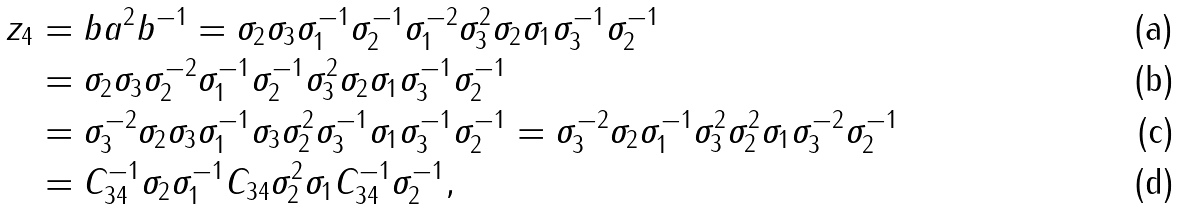Convert formula to latex. <formula><loc_0><loc_0><loc_500><loc_500>z _ { 4 } & = b a ^ { 2 } b ^ { - 1 } = \sigma _ { 2 } \sigma _ { 3 } \sigma _ { 1 } ^ { - 1 } \sigma _ { 2 } ^ { - 1 } \sigma _ { 1 } ^ { - 2 } \sigma _ { 3 } ^ { 2 } \sigma _ { 2 } \sigma _ { 1 } \sigma _ { 3 } ^ { - 1 } \sigma _ { 2 } ^ { - 1 } \\ & = \sigma _ { 2 } \sigma _ { 3 } \sigma _ { 2 } ^ { - 2 } \sigma _ { 1 } ^ { - 1 } \sigma _ { 2 } ^ { - 1 } \sigma _ { 3 } ^ { 2 } \sigma _ { 2 } \sigma _ { 1 } \sigma _ { 3 } ^ { - 1 } \sigma _ { 2 } ^ { - 1 } \\ & = \sigma _ { 3 } ^ { - 2 } \sigma _ { 2 } \sigma _ { 3 } \sigma _ { 1 } ^ { - 1 } \sigma _ { 3 } \sigma _ { 2 } ^ { 2 } \sigma _ { 3 } ^ { - 1 } \sigma _ { 1 } \sigma _ { 3 } ^ { - 1 } \sigma _ { 2 } ^ { - 1 } = \sigma _ { 3 } ^ { - 2 } \sigma _ { 2 } \sigma _ { 1 } ^ { - 1 } \sigma _ { 3 } ^ { 2 } \sigma _ { 2 } ^ { 2 } \sigma _ { 1 } \sigma _ { 3 } ^ { - 2 } \sigma _ { 2 } ^ { - 1 } \\ & = C _ { 3 4 } ^ { - 1 } \sigma _ { 2 } \sigma _ { 1 } ^ { - 1 } C _ { 3 4 } \sigma _ { 2 } ^ { 2 } \sigma _ { 1 } C _ { 3 4 } ^ { - 1 } \sigma _ { 2 } ^ { - 1 } ,</formula> 